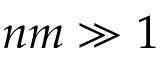Convert formula to latex. <formula><loc_0><loc_0><loc_500><loc_500>n m \gg 1</formula> 